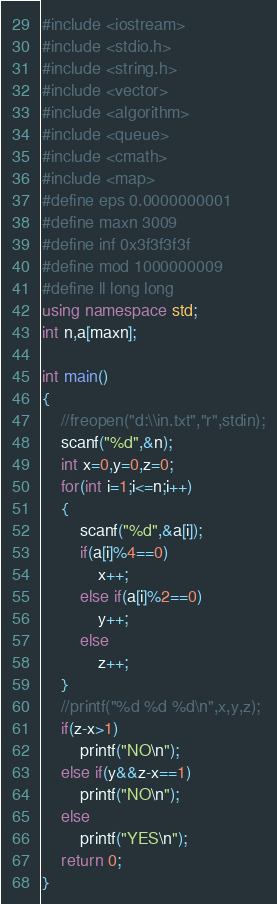<code> <loc_0><loc_0><loc_500><loc_500><_C++_>#include <iostream>
#include <stdio.h>
#include <string.h>
#include <vector>
#include <algorithm>
#include <queue>
#include <cmath>
#include <map>
#define eps 0.0000000001
#define maxn 3009
#define inf 0x3f3f3f3f
#define mod 1000000009
#define ll long long
using namespace std;
int n,a[maxn];

int main()
{
    //freopen("d:\\in.txt","r",stdin);
    scanf("%d",&n);
    int x=0,y=0,z=0;
    for(int i=1;i<=n;i++)
    {
        scanf("%d",&a[i]);
        if(a[i]%4==0)
            x++;
        else if(a[i]%2==0)
            y++;
        else
            z++;
    }
    //printf("%d %d %d\n",x,y,z);
    if(z-x>1)
        printf("NO\n");
    else if(y&&z-x==1)
        printf("NO\n");
    else
        printf("YES\n");
    return 0;
}
</code> 